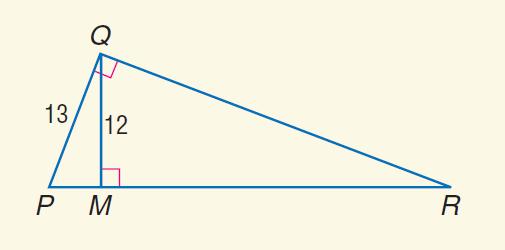Answer the mathemtical geometry problem and directly provide the correct option letter.
Question: Find the perimeter of \triangle P Q R, if \triangle P Q M \sim \triangle P R Q.
Choices: A: 30 B: 65 C: 78 D: 81 C 